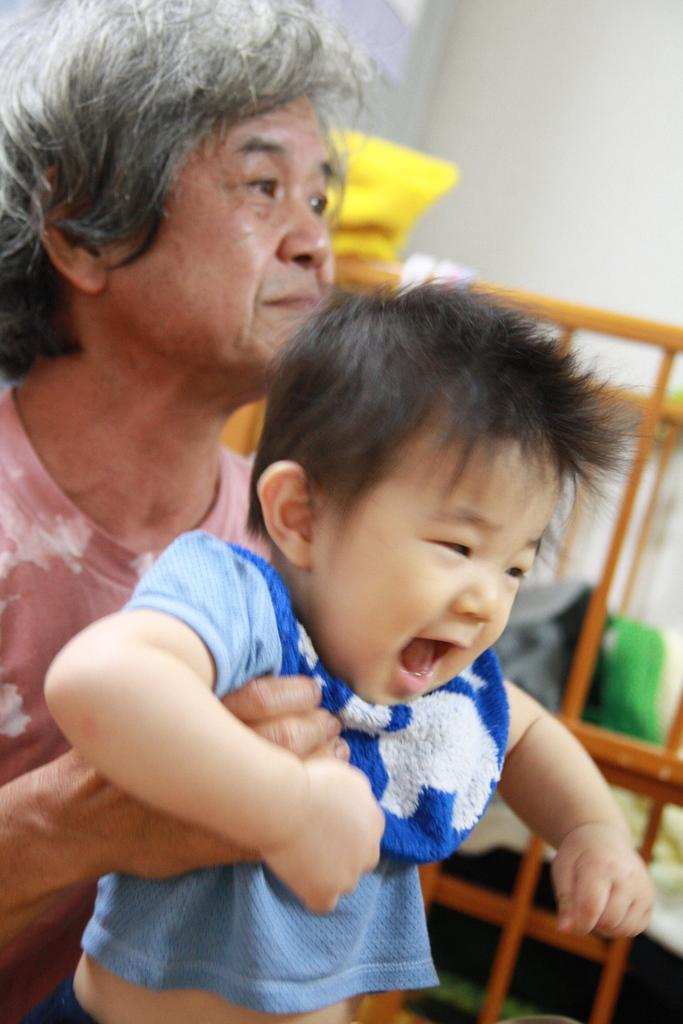What is the woman in the image doing? The woman is holding a kid in the image. What can be seen in the background of the image? There is a bed, a wooden fence, clothes, and a wall visible in the background of the image. What month is the woman holding the kid in the image? The month is not mentioned or visible in the image, so it cannot be determined. 